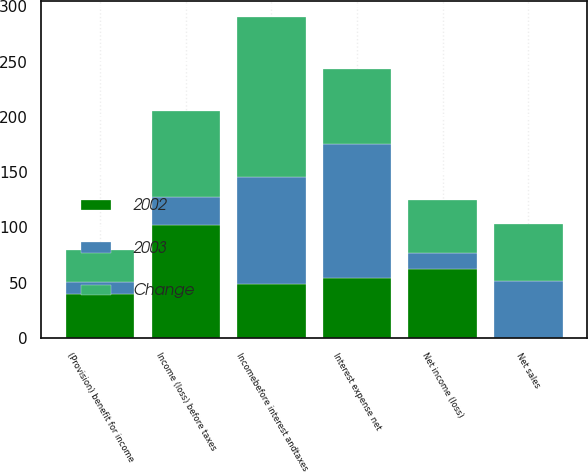<chart> <loc_0><loc_0><loc_500><loc_500><stacked_bar_chart><ecel><fcel>Net sales<fcel>Incomebefore interest andtaxes<fcel>Interest expense net<fcel>Income (loss) before taxes<fcel>(Provision) benefit for income<fcel>Net income (loss)<nl><fcel>2003<fcel>51.25<fcel>96.9<fcel>121.8<fcel>24.9<fcel>10.5<fcel>14.4<nl><fcel>Change<fcel>51.25<fcel>145.3<fcel>67.7<fcel>77.6<fcel>29.4<fcel>48.2<nl><fcel>2002<fcel>0.4<fcel>48.4<fcel>54.1<fcel>102.5<fcel>39.9<fcel>62.6<nl></chart> 